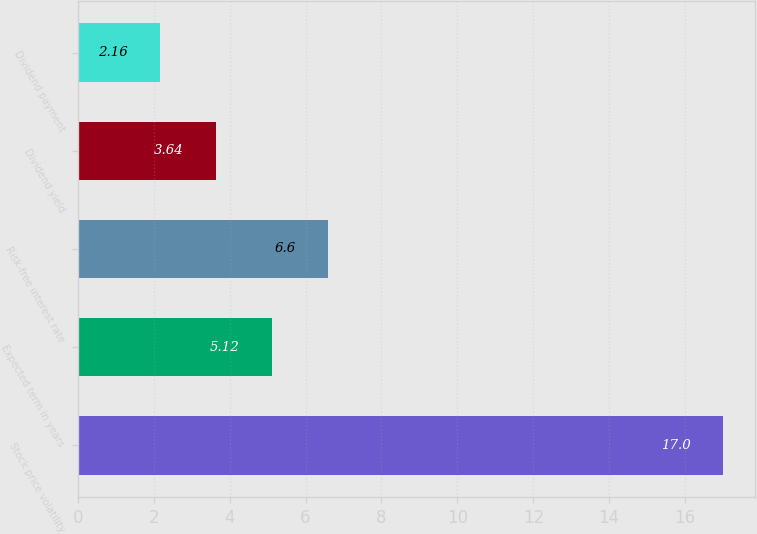Convert chart to OTSL. <chart><loc_0><loc_0><loc_500><loc_500><bar_chart><fcel>Stock price volatility<fcel>Expected term in years<fcel>Risk-free interest rate<fcel>Dividend yield<fcel>Dividend payment<nl><fcel>17<fcel>5.12<fcel>6.6<fcel>3.64<fcel>2.16<nl></chart> 